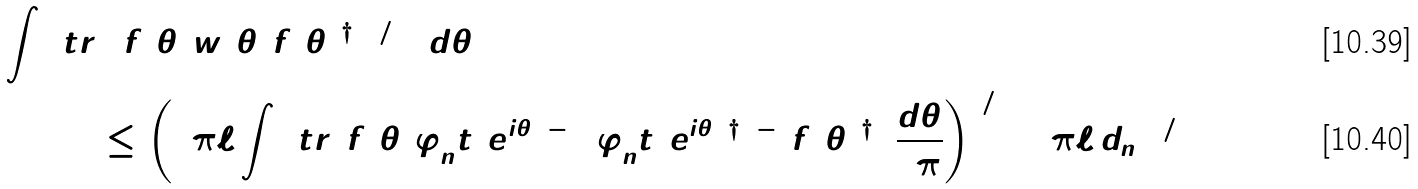<formula> <loc_0><loc_0><loc_500><loc_500>\int _ { \Omega } \ t r & ( [ f ( \theta ) w ( \theta ) f ( \theta ) ^ { \dagger } ] ^ { 1 / 4 } ) \, d \theta \\ & \leq \left ( 2 \pi \ell \int _ { \Omega } \ t r ( f ( \theta ) \varphi _ { n } ^ { \L } t ( e ^ { i \theta } ) ^ { - 1 } ( \varphi _ { n } ^ { \L } t ( e ^ { i \theta } ) ^ { \dagger } ) ^ { - 1 } f ( \theta ) ^ { \dagger } ) \, \frac { d \theta } { 2 \pi } \right ) ^ { 1 / 4 } ( 2 \pi \ell \, d _ { n } ) ^ { 1 / 2 }</formula> 